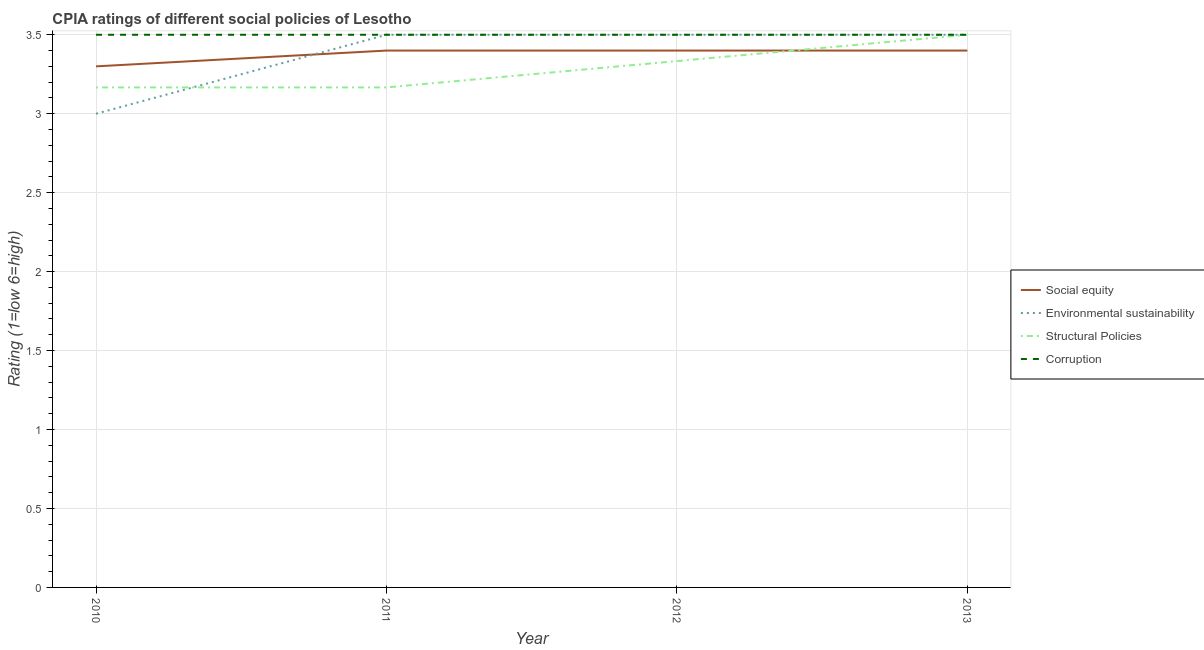Is the number of lines equal to the number of legend labels?
Your answer should be very brief. Yes. What is the cpia rating of corruption in 2013?
Ensure brevity in your answer.  3.5. Across all years, what is the minimum cpia rating of structural policies?
Your response must be concise. 3.17. What is the total cpia rating of environmental sustainability in the graph?
Provide a succinct answer. 13.5. What is the average cpia rating of structural policies per year?
Provide a succinct answer. 3.29. In the year 2013, what is the difference between the cpia rating of social equity and cpia rating of environmental sustainability?
Offer a terse response. -0.1. In how many years, is the cpia rating of environmental sustainability greater than 2.7?
Ensure brevity in your answer.  4. What is the ratio of the cpia rating of environmental sustainability in 2011 to that in 2013?
Your answer should be compact. 1. Is the difference between the cpia rating of environmental sustainability in 2010 and 2011 greater than the difference between the cpia rating of corruption in 2010 and 2011?
Your answer should be very brief. No. What is the difference between the highest and the second highest cpia rating of corruption?
Your response must be concise. 0. What is the difference between the highest and the lowest cpia rating of structural policies?
Give a very brief answer. 0.33. In how many years, is the cpia rating of environmental sustainability greater than the average cpia rating of environmental sustainability taken over all years?
Ensure brevity in your answer.  3. Is the sum of the cpia rating of environmental sustainability in 2011 and 2012 greater than the maximum cpia rating of structural policies across all years?
Offer a very short reply. Yes. Is it the case that in every year, the sum of the cpia rating of structural policies and cpia rating of environmental sustainability is greater than the sum of cpia rating of corruption and cpia rating of social equity?
Offer a terse response. No. Does the cpia rating of structural policies monotonically increase over the years?
Your response must be concise. No. Is the cpia rating of social equity strictly greater than the cpia rating of corruption over the years?
Ensure brevity in your answer.  No. What is the difference between two consecutive major ticks on the Y-axis?
Provide a short and direct response. 0.5. Does the graph contain grids?
Your response must be concise. Yes. Where does the legend appear in the graph?
Offer a very short reply. Center right. What is the title of the graph?
Your answer should be compact. CPIA ratings of different social policies of Lesotho. Does "Secondary general education" appear as one of the legend labels in the graph?
Keep it short and to the point. No. What is the label or title of the X-axis?
Your answer should be very brief. Year. What is the label or title of the Y-axis?
Give a very brief answer. Rating (1=low 6=high). What is the Rating (1=low 6=high) in Structural Policies in 2010?
Keep it short and to the point. 3.17. What is the Rating (1=low 6=high) in Social equity in 2011?
Provide a succinct answer. 3.4. What is the Rating (1=low 6=high) of Structural Policies in 2011?
Keep it short and to the point. 3.17. What is the Rating (1=low 6=high) in Social equity in 2012?
Ensure brevity in your answer.  3.4. What is the Rating (1=low 6=high) in Structural Policies in 2012?
Keep it short and to the point. 3.33. What is the Rating (1=low 6=high) in Corruption in 2012?
Ensure brevity in your answer.  3.5. Across all years, what is the maximum Rating (1=low 6=high) of Environmental sustainability?
Provide a succinct answer. 3.5. Across all years, what is the maximum Rating (1=low 6=high) in Structural Policies?
Give a very brief answer. 3.5. Across all years, what is the maximum Rating (1=low 6=high) in Corruption?
Make the answer very short. 3.5. Across all years, what is the minimum Rating (1=low 6=high) in Structural Policies?
Your answer should be very brief. 3.17. What is the total Rating (1=low 6=high) of Social equity in the graph?
Keep it short and to the point. 13.5. What is the total Rating (1=low 6=high) in Environmental sustainability in the graph?
Provide a succinct answer. 13.5. What is the total Rating (1=low 6=high) in Structural Policies in the graph?
Offer a very short reply. 13.17. What is the total Rating (1=low 6=high) of Corruption in the graph?
Give a very brief answer. 14. What is the difference between the Rating (1=low 6=high) of Environmental sustainability in 2010 and that in 2011?
Your answer should be compact. -0.5. What is the difference between the Rating (1=low 6=high) in Corruption in 2010 and that in 2011?
Offer a terse response. 0. What is the difference between the Rating (1=low 6=high) in Social equity in 2010 and that in 2012?
Ensure brevity in your answer.  -0.1. What is the difference between the Rating (1=low 6=high) of Environmental sustainability in 2010 and that in 2012?
Make the answer very short. -0.5. What is the difference between the Rating (1=low 6=high) in Structural Policies in 2010 and that in 2012?
Offer a terse response. -0.17. What is the difference between the Rating (1=low 6=high) of Corruption in 2010 and that in 2012?
Your answer should be very brief. 0. What is the difference between the Rating (1=low 6=high) in Environmental sustainability in 2010 and that in 2013?
Provide a short and direct response. -0.5. What is the difference between the Rating (1=low 6=high) in Structural Policies in 2010 and that in 2013?
Your answer should be compact. -0.33. What is the difference between the Rating (1=low 6=high) of Corruption in 2010 and that in 2013?
Give a very brief answer. 0. What is the difference between the Rating (1=low 6=high) in Structural Policies in 2011 and that in 2012?
Provide a short and direct response. -0.17. What is the difference between the Rating (1=low 6=high) in Environmental sustainability in 2011 and that in 2013?
Provide a succinct answer. 0. What is the difference between the Rating (1=low 6=high) of Structural Policies in 2011 and that in 2013?
Your answer should be compact. -0.33. What is the difference between the Rating (1=low 6=high) of Corruption in 2011 and that in 2013?
Offer a very short reply. 0. What is the difference between the Rating (1=low 6=high) in Structural Policies in 2012 and that in 2013?
Your answer should be compact. -0.17. What is the difference between the Rating (1=low 6=high) in Corruption in 2012 and that in 2013?
Your answer should be compact. 0. What is the difference between the Rating (1=low 6=high) of Social equity in 2010 and the Rating (1=low 6=high) of Structural Policies in 2011?
Your response must be concise. 0.13. What is the difference between the Rating (1=low 6=high) of Social equity in 2010 and the Rating (1=low 6=high) of Environmental sustainability in 2012?
Give a very brief answer. -0.2. What is the difference between the Rating (1=low 6=high) of Social equity in 2010 and the Rating (1=low 6=high) of Structural Policies in 2012?
Offer a terse response. -0.03. What is the difference between the Rating (1=low 6=high) of Social equity in 2010 and the Rating (1=low 6=high) of Corruption in 2012?
Make the answer very short. -0.2. What is the difference between the Rating (1=low 6=high) of Environmental sustainability in 2010 and the Rating (1=low 6=high) of Structural Policies in 2012?
Your answer should be compact. -0.33. What is the difference between the Rating (1=low 6=high) in Environmental sustainability in 2010 and the Rating (1=low 6=high) in Corruption in 2012?
Offer a terse response. -0.5. What is the difference between the Rating (1=low 6=high) in Structural Policies in 2010 and the Rating (1=low 6=high) in Corruption in 2012?
Provide a succinct answer. -0.33. What is the difference between the Rating (1=low 6=high) of Social equity in 2010 and the Rating (1=low 6=high) of Environmental sustainability in 2013?
Your answer should be very brief. -0.2. What is the difference between the Rating (1=low 6=high) of Structural Policies in 2010 and the Rating (1=low 6=high) of Corruption in 2013?
Offer a very short reply. -0.33. What is the difference between the Rating (1=low 6=high) in Social equity in 2011 and the Rating (1=low 6=high) in Structural Policies in 2012?
Give a very brief answer. 0.07. What is the difference between the Rating (1=low 6=high) of Environmental sustainability in 2011 and the Rating (1=low 6=high) of Structural Policies in 2012?
Provide a succinct answer. 0.17. What is the difference between the Rating (1=low 6=high) in Structural Policies in 2011 and the Rating (1=low 6=high) in Corruption in 2012?
Your answer should be very brief. -0.33. What is the difference between the Rating (1=low 6=high) of Social equity in 2011 and the Rating (1=low 6=high) of Environmental sustainability in 2013?
Keep it short and to the point. -0.1. What is the difference between the Rating (1=low 6=high) of Social equity in 2011 and the Rating (1=low 6=high) of Structural Policies in 2013?
Offer a terse response. -0.1. What is the difference between the Rating (1=low 6=high) of Social equity in 2011 and the Rating (1=low 6=high) of Corruption in 2013?
Make the answer very short. -0.1. What is the difference between the Rating (1=low 6=high) in Environmental sustainability in 2011 and the Rating (1=low 6=high) in Structural Policies in 2013?
Keep it short and to the point. 0. What is the difference between the Rating (1=low 6=high) of Environmental sustainability in 2011 and the Rating (1=low 6=high) of Corruption in 2013?
Give a very brief answer. 0. What is the difference between the Rating (1=low 6=high) of Structural Policies in 2011 and the Rating (1=low 6=high) of Corruption in 2013?
Your answer should be very brief. -0.33. What is the difference between the Rating (1=low 6=high) in Social equity in 2012 and the Rating (1=low 6=high) in Environmental sustainability in 2013?
Make the answer very short. -0.1. What is the difference between the Rating (1=low 6=high) in Social equity in 2012 and the Rating (1=low 6=high) in Structural Policies in 2013?
Keep it short and to the point. -0.1. What is the difference between the Rating (1=low 6=high) of Structural Policies in 2012 and the Rating (1=low 6=high) of Corruption in 2013?
Keep it short and to the point. -0.17. What is the average Rating (1=low 6=high) in Social equity per year?
Provide a succinct answer. 3.38. What is the average Rating (1=low 6=high) in Environmental sustainability per year?
Make the answer very short. 3.38. What is the average Rating (1=low 6=high) in Structural Policies per year?
Your answer should be very brief. 3.29. What is the average Rating (1=low 6=high) of Corruption per year?
Make the answer very short. 3.5. In the year 2010, what is the difference between the Rating (1=low 6=high) of Social equity and Rating (1=low 6=high) of Environmental sustainability?
Give a very brief answer. 0.3. In the year 2010, what is the difference between the Rating (1=low 6=high) of Social equity and Rating (1=low 6=high) of Structural Policies?
Provide a short and direct response. 0.13. In the year 2010, what is the difference between the Rating (1=low 6=high) in Environmental sustainability and Rating (1=low 6=high) in Corruption?
Offer a terse response. -0.5. In the year 2010, what is the difference between the Rating (1=low 6=high) of Structural Policies and Rating (1=low 6=high) of Corruption?
Ensure brevity in your answer.  -0.33. In the year 2011, what is the difference between the Rating (1=low 6=high) in Social equity and Rating (1=low 6=high) in Environmental sustainability?
Provide a succinct answer. -0.1. In the year 2011, what is the difference between the Rating (1=low 6=high) of Social equity and Rating (1=low 6=high) of Structural Policies?
Your answer should be compact. 0.23. In the year 2011, what is the difference between the Rating (1=low 6=high) in Environmental sustainability and Rating (1=low 6=high) in Structural Policies?
Make the answer very short. 0.33. In the year 2011, what is the difference between the Rating (1=low 6=high) in Environmental sustainability and Rating (1=low 6=high) in Corruption?
Make the answer very short. 0. In the year 2012, what is the difference between the Rating (1=low 6=high) in Social equity and Rating (1=low 6=high) in Environmental sustainability?
Provide a short and direct response. -0.1. In the year 2012, what is the difference between the Rating (1=low 6=high) in Social equity and Rating (1=low 6=high) in Structural Policies?
Your answer should be very brief. 0.07. In the year 2012, what is the difference between the Rating (1=low 6=high) of Social equity and Rating (1=low 6=high) of Corruption?
Provide a succinct answer. -0.1. In the year 2012, what is the difference between the Rating (1=low 6=high) in Environmental sustainability and Rating (1=low 6=high) in Corruption?
Give a very brief answer. 0. In the year 2013, what is the difference between the Rating (1=low 6=high) in Social equity and Rating (1=low 6=high) in Environmental sustainability?
Keep it short and to the point. -0.1. In the year 2013, what is the difference between the Rating (1=low 6=high) in Social equity and Rating (1=low 6=high) in Structural Policies?
Provide a short and direct response. -0.1. In the year 2013, what is the difference between the Rating (1=low 6=high) in Social equity and Rating (1=low 6=high) in Corruption?
Keep it short and to the point. -0.1. In the year 2013, what is the difference between the Rating (1=low 6=high) of Environmental sustainability and Rating (1=low 6=high) of Structural Policies?
Provide a succinct answer. 0. What is the ratio of the Rating (1=low 6=high) in Social equity in 2010 to that in 2011?
Your answer should be very brief. 0.97. What is the ratio of the Rating (1=low 6=high) in Environmental sustainability in 2010 to that in 2011?
Ensure brevity in your answer.  0.86. What is the ratio of the Rating (1=low 6=high) in Social equity in 2010 to that in 2012?
Ensure brevity in your answer.  0.97. What is the ratio of the Rating (1=low 6=high) in Structural Policies in 2010 to that in 2012?
Give a very brief answer. 0.95. What is the ratio of the Rating (1=low 6=high) of Corruption in 2010 to that in 2012?
Give a very brief answer. 1. What is the ratio of the Rating (1=low 6=high) of Social equity in 2010 to that in 2013?
Make the answer very short. 0.97. What is the ratio of the Rating (1=low 6=high) of Environmental sustainability in 2010 to that in 2013?
Provide a short and direct response. 0.86. What is the ratio of the Rating (1=low 6=high) of Structural Policies in 2010 to that in 2013?
Your answer should be very brief. 0.9. What is the ratio of the Rating (1=low 6=high) in Corruption in 2010 to that in 2013?
Provide a short and direct response. 1. What is the ratio of the Rating (1=low 6=high) of Social equity in 2011 to that in 2012?
Your answer should be compact. 1. What is the ratio of the Rating (1=low 6=high) of Environmental sustainability in 2011 to that in 2012?
Your answer should be very brief. 1. What is the ratio of the Rating (1=low 6=high) of Structural Policies in 2011 to that in 2012?
Offer a very short reply. 0.95. What is the ratio of the Rating (1=low 6=high) of Social equity in 2011 to that in 2013?
Offer a very short reply. 1. What is the ratio of the Rating (1=low 6=high) in Structural Policies in 2011 to that in 2013?
Provide a short and direct response. 0.9. What is the ratio of the Rating (1=low 6=high) in Corruption in 2011 to that in 2013?
Offer a terse response. 1. What is the ratio of the Rating (1=low 6=high) of Social equity in 2012 to that in 2013?
Your response must be concise. 1. What is the difference between the highest and the second highest Rating (1=low 6=high) of Social equity?
Your answer should be very brief. 0. What is the difference between the highest and the second highest Rating (1=low 6=high) of Environmental sustainability?
Offer a very short reply. 0. What is the difference between the highest and the second highest Rating (1=low 6=high) in Structural Policies?
Make the answer very short. 0.17. What is the difference between the highest and the second highest Rating (1=low 6=high) in Corruption?
Offer a very short reply. 0. What is the difference between the highest and the lowest Rating (1=low 6=high) in Environmental sustainability?
Make the answer very short. 0.5. What is the difference between the highest and the lowest Rating (1=low 6=high) of Structural Policies?
Offer a very short reply. 0.33. What is the difference between the highest and the lowest Rating (1=low 6=high) of Corruption?
Your answer should be very brief. 0. 